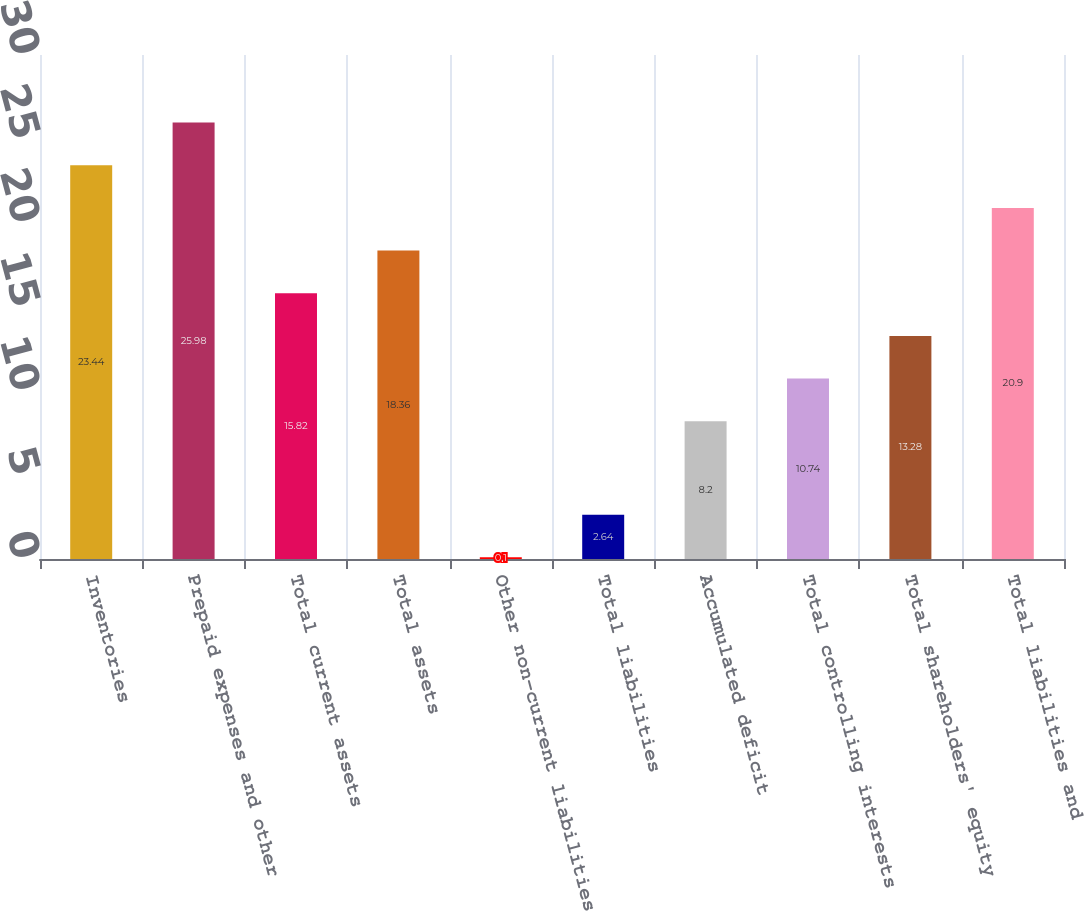<chart> <loc_0><loc_0><loc_500><loc_500><bar_chart><fcel>Inventories<fcel>Prepaid expenses and other<fcel>Total current assets<fcel>Total assets<fcel>Other non-current liabilities<fcel>Total liabilities<fcel>Accumulated deficit<fcel>Total controlling interests<fcel>Total shareholders' equity<fcel>Total liabilities and<nl><fcel>23.44<fcel>25.98<fcel>15.82<fcel>18.36<fcel>0.1<fcel>2.64<fcel>8.2<fcel>10.74<fcel>13.28<fcel>20.9<nl></chart> 